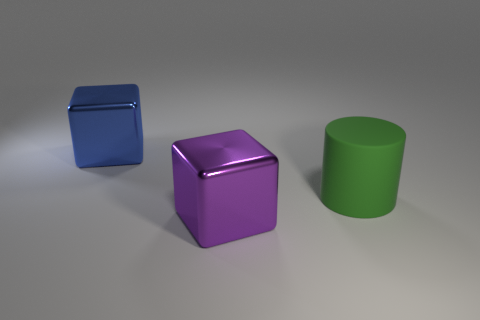Add 2 big blue metallic things. How many objects exist? 5 Subtract 1 cubes. How many cubes are left? 1 Subtract all cylinders. How many objects are left? 2 Subtract all red blocks. Subtract all brown balls. How many blocks are left? 2 Subtract all blue spheres. How many blue blocks are left? 1 Subtract all blue blocks. Subtract all cylinders. How many objects are left? 1 Add 1 blue cubes. How many blue cubes are left? 2 Add 3 green balls. How many green balls exist? 3 Subtract 0 blue cylinders. How many objects are left? 3 